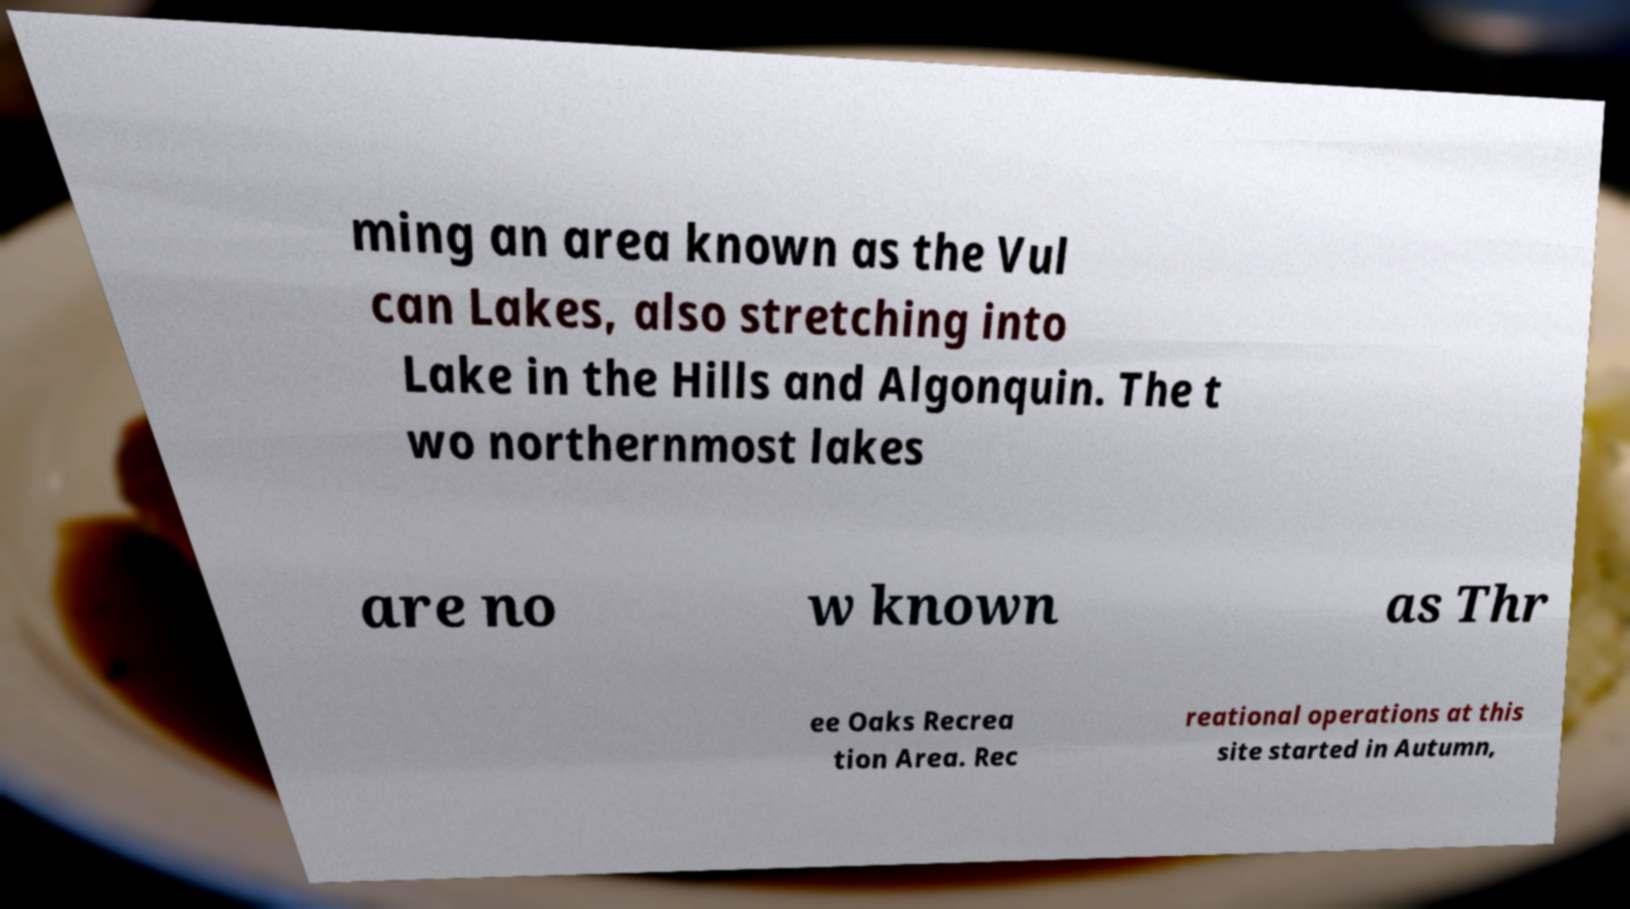Please read and relay the text visible in this image. What does it say? ming an area known as the Vul can Lakes, also stretching into Lake in the Hills and Algonquin. The t wo northernmost lakes are no w known as Thr ee Oaks Recrea tion Area. Rec reational operations at this site started in Autumn, 